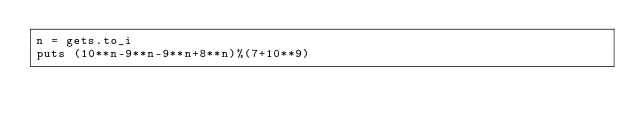<code> <loc_0><loc_0><loc_500><loc_500><_Ruby_>n = gets.to_i
puts (10**n-9**n-9**n+8**n)%(7+10**9)</code> 